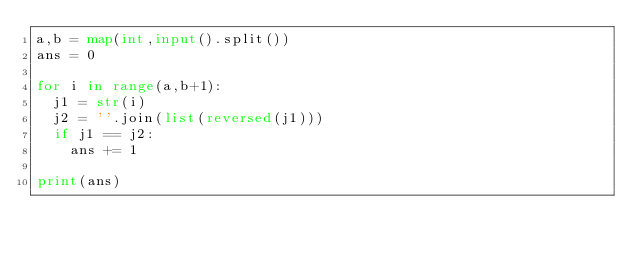<code> <loc_0><loc_0><loc_500><loc_500><_Python_>a,b = map(int,input().split())
ans = 0

for i in range(a,b+1):
  j1 = str(i)
  j2 = ''.join(list(reversed(j1)))
  if j1 == j2:
    ans += 1

print(ans)</code> 